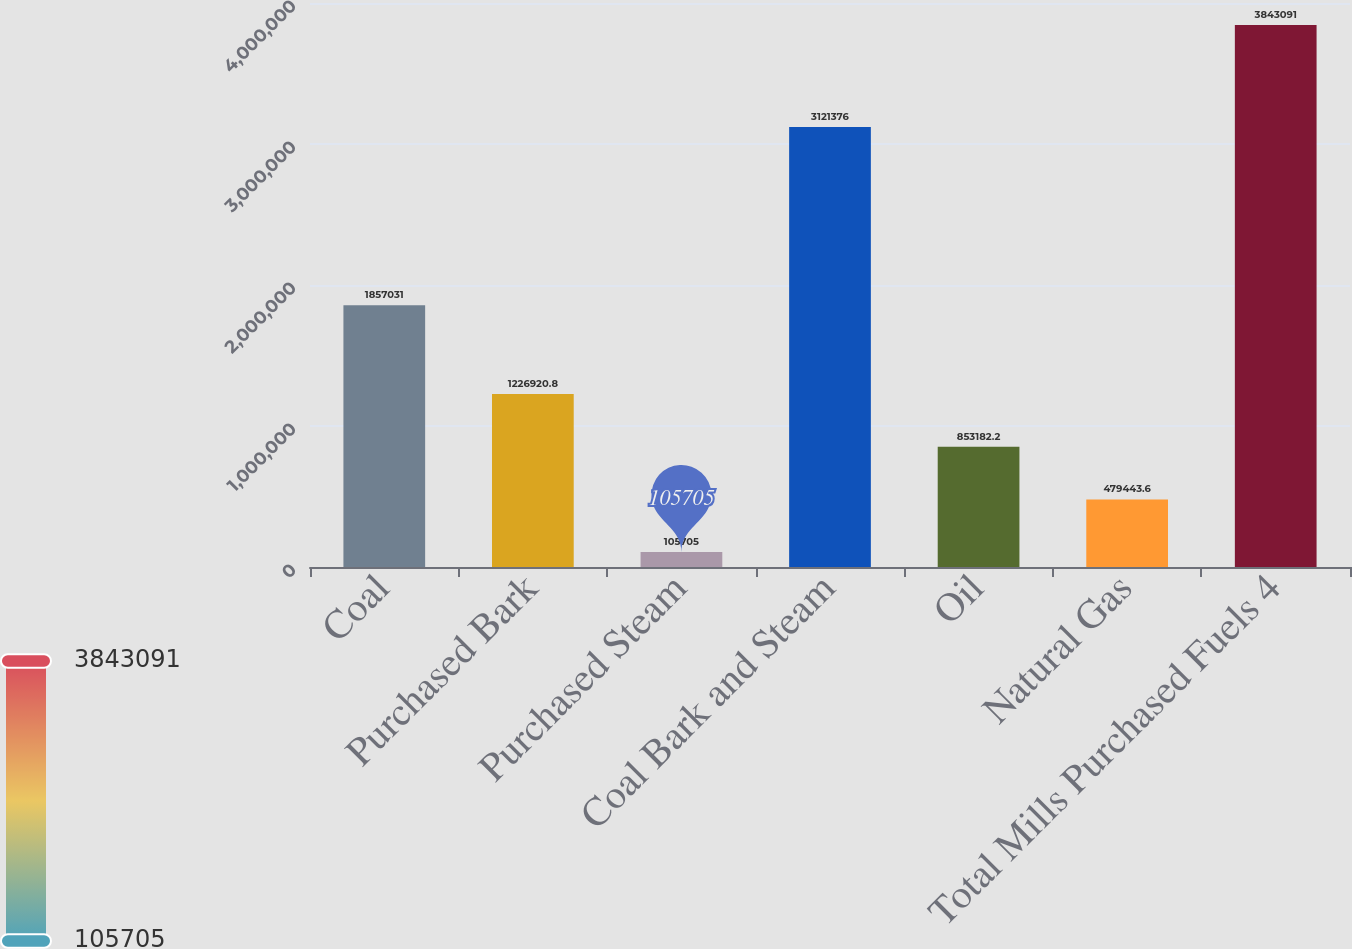Convert chart. <chart><loc_0><loc_0><loc_500><loc_500><bar_chart><fcel>Coal<fcel>Purchased Bark<fcel>Purchased Steam<fcel>Coal Bark and Steam<fcel>Oil<fcel>Natural Gas<fcel>Total Mills Purchased Fuels 4<nl><fcel>1.85703e+06<fcel>1.22692e+06<fcel>105705<fcel>3.12138e+06<fcel>853182<fcel>479444<fcel>3.84309e+06<nl></chart> 